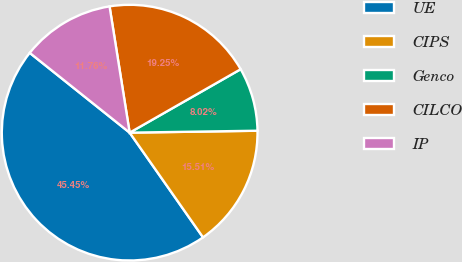Convert chart. <chart><loc_0><loc_0><loc_500><loc_500><pie_chart><fcel>UE<fcel>CIPS<fcel>Genco<fcel>CILCO<fcel>IP<nl><fcel>45.45%<fcel>15.51%<fcel>8.02%<fcel>19.25%<fcel>11.76%<nl></chart> 